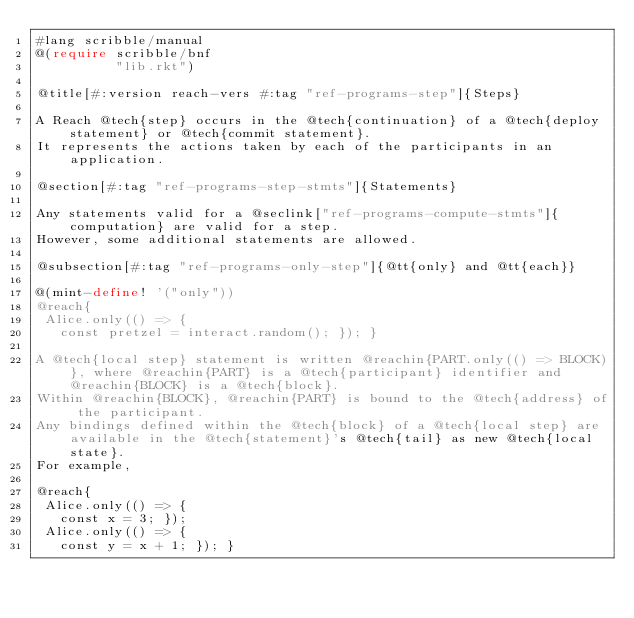<code> <loc_0><loc_0><loc_500><loc_500><_Racket_>#lang scribble/manual
@(require scribble/bnf
          "lib.rkt")

@title[#:version reach-vers #:tag "ref-programs-step"]{Steps}

A Reach @tech{step} occurs in the @tech{continuation} of a @tech{deploy statement} or @tech{commit statement}.
It represents the actions taken by each of the participants in an application.

@section[#:tag "ref-programs-step-stmts"]{Statements}

Any statements valid for a @seclink["ref-programs-compute-stmts"]{computation} are valid for a step.
However, some additional statements are allowed.

@subsection[#:tag "ref-programs-only-step"]{@tt{only} and @tt{each}}

@(mint-define! '("only"))
@reach{
 Alice.only(() => {
   const pretzel = interact.random(); }); }

A @tech{local step} statement is written @reachin{PART.only(() => BLOCK)}, where @reachin{PART} is a @tech{participant} identifier and @reachin{BLOCK} is a @tech{block}.
Within @reachin{BLOCK}, @reachin{PART} is bound to the @tech{address} of the participant.
Any bindings defined within the @tech{block} of a @tech{local step} are available in the @tech{statement}'s @tech{tail} as new @tech{local state}.
For example,

@reach{
 Alice.only(() => {
   const x = 3; });
 Alice.only(() => {
   const y = x + 1; }); }
</code> 